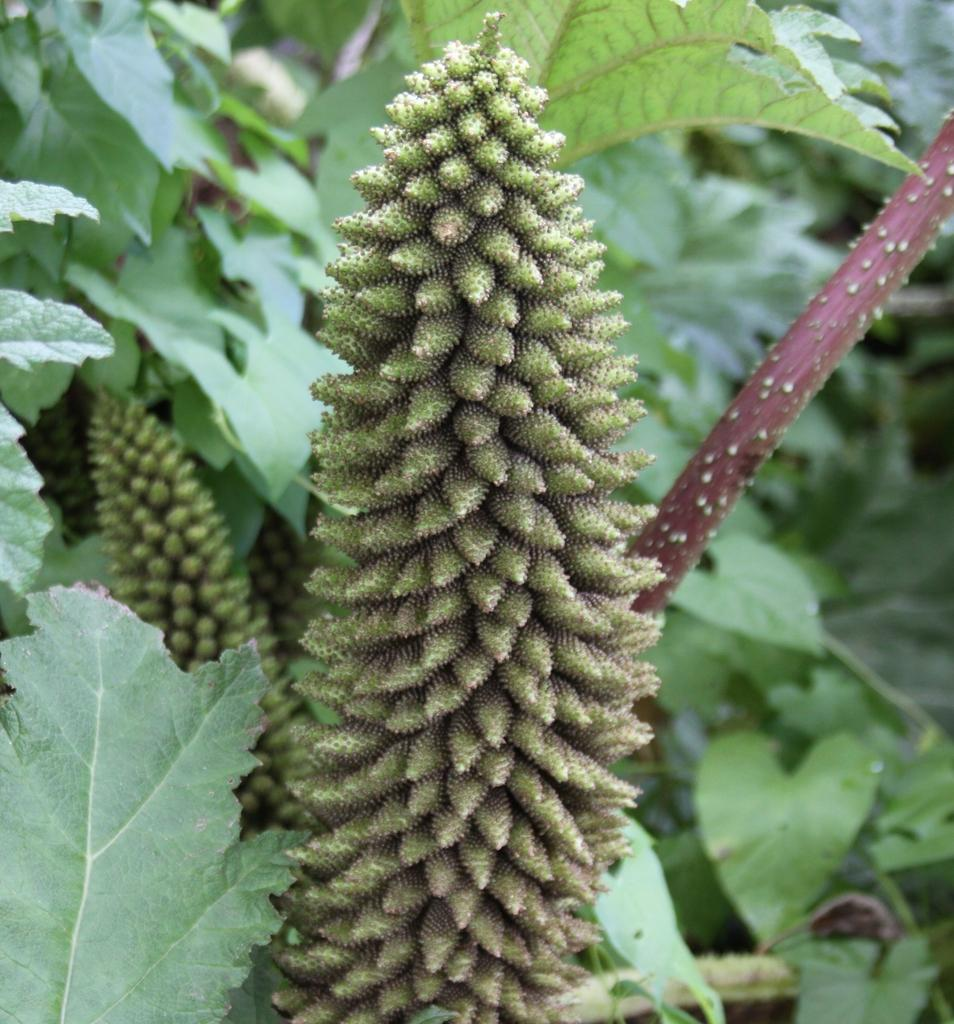What type of living organisms can be seen in the image? Plants can be seen in the image. Do the plants in the image have any specific features? Yes, the plants have flowers. How many eggs are visible in the image? There are no eggs present in the image, as it features plants with flowers. What type of feast is being prepared in the image? There is no feast being prepared in the image; it only shows plants with flowers. 